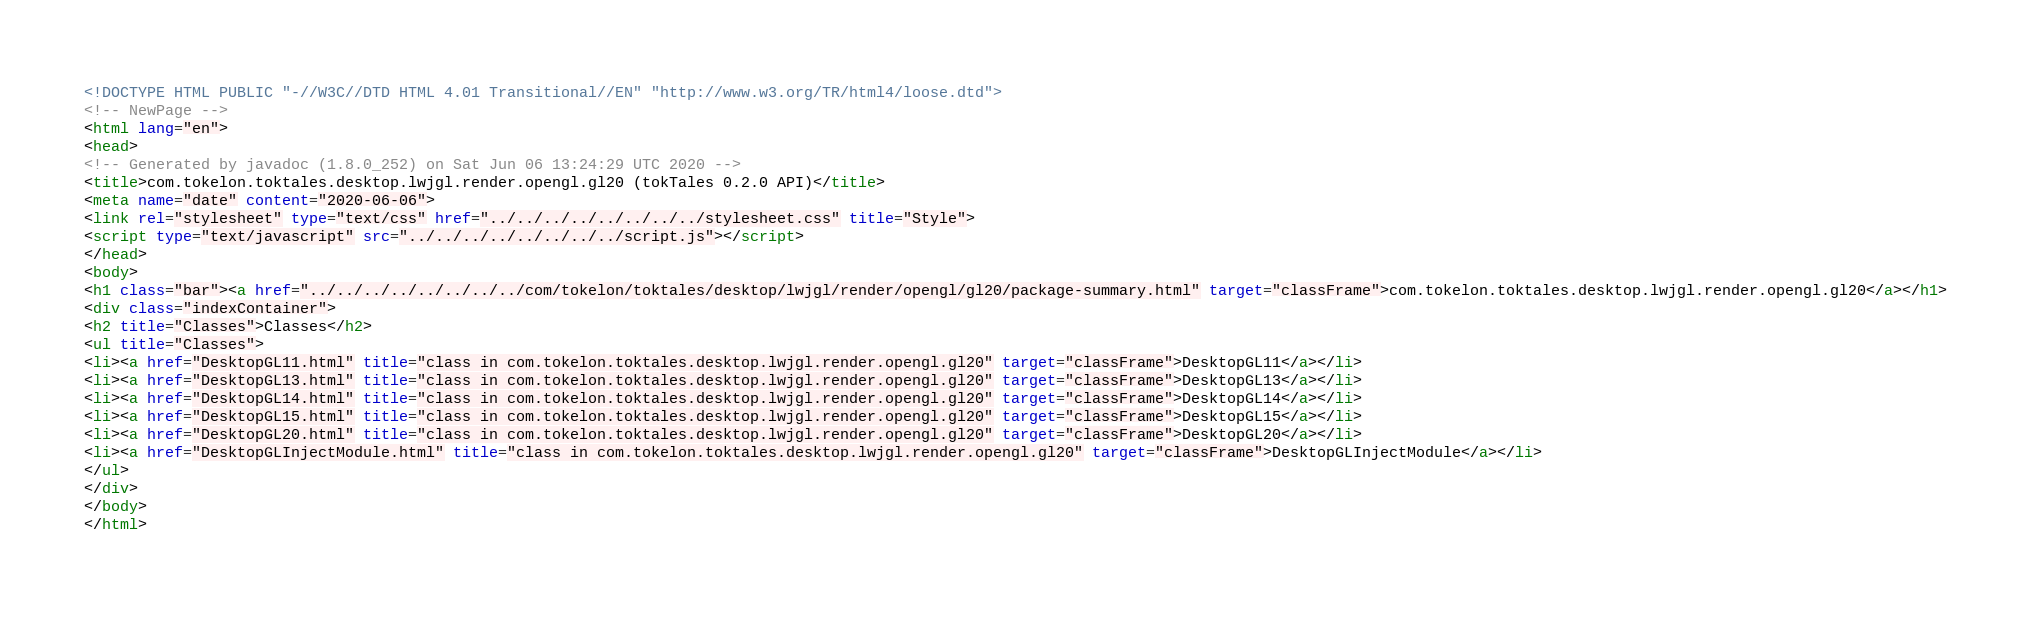<code> <loc_0><loc_0><loc_500><loc_500><_HTML_><!DOCTYPE HTML PUBLIC "-//W3C//DTD HTML 4.01 Transitional//EN" "http://www.w3.org/TR/html4/loose.dtd">
<!-- NewPage -->
<html lang="en">
<head>
<!-- Generated by javadoc (1.8.0_252) on Sat Jun 06 13:24:29 UTC 2020 -->
<title>com.tokelon.toktales.desktop.lwjgl.render.opengl.gl20 (tokTales 0.2.0 API)</title>
<meta name="date" content="2020-06-06">
<link rel="stylesheet" type="text/css" href="../../../../../../../../stylesheet.css" title="Style">
<script type="text/javascript" src="../../../../../../../../script.js"></script>
</head>
<body>
<h1 class="bar"><a href="../../../../../../../../com/tokelon/toktales/desktop/lwjgl/render/opengl/gl20/package-summary.html" target="classFrame">com.tokelon.toktales.desktop.lwjgl.render.opengl.gl20</a></h1>
<div class="indexContainer">
<h2 title="Classes">Classes</h2>
<ul title="Classes">
<li><a href="DesktopGL11.html" title="class in com.tokelon.toktales.desktop.lwjgl.render.opengl.gl20" target="classFrame">DesktopGL11</a></li>
<li><a href="DesktopGL13.html" title="class in com.tokelon.toktales.desktop.lwjgl.render.opengl.gl20" target="classFrame">DesktopGL13</a></li>
<li><a href="DesktopGL14.html" title="class in com.tokelon.toktales.desktop.lwjgl.render.opengl.gl20" target="classFrame">DesktopGL14</a></li>
<li><a href="DesktopGL15.html" title="class in com.tokelon.toktales.desktop.lwjgl.render.opengl.gl20" target="classFrame">DesktopGL15</a></li>
<li><a href="DesktopGL20.html" title="class in com.tokelon.toktales.desktop.lwjgl.render.opengl.gl20" target="classFrame">DesktopGL20</a></li>
<li><a href="DesktopGLInjectModule.html" title="class in com.tokelon.toktales.desktop.lwjgl.render.opengl.gl20" target="classFrame">DesktopGLInjectModule</a></li>
</ul>
</div>
</body>
</html>
</code> 